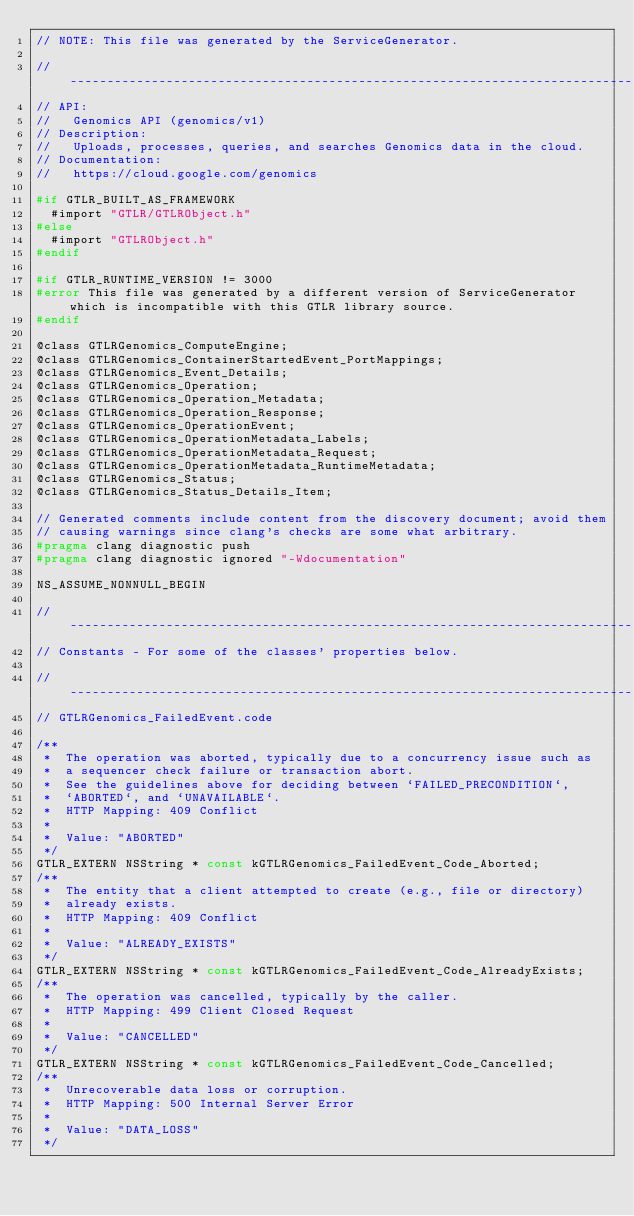Convert code to text. <code><loc_0><loc_0><loc_500><loc_500><_C_>// NOTE: This file was generated by the ServiceGenerator.

// ----------------------------------------------------------------------------
// API:
//   Genomics API (genomics/v1)
// Description:
//   Uploads, processes, queries, and searches Genomics data in the cloud.
// Documentation:
//   https://cloud.google.com/genomics

#if GTLR_BUILT_AS_FRAMEWORK
  #import "GTLR/GTLRObject.h"
#else
  #import "GTLRObject.h"
#endif

#if GTLR_RUNTIME_VERSION != 3000
#error This file was generated by a different version of ServiceGenerator which is incompatible with this GTLR library source.
#endif

@class GTLRGenomics_ComputeEngine;
@class GTLRGenomics_ContainerStartedEvent_PortMappings;
@class GTLRGenomics_Event_Details;
@class GTLRGenomics_Operation;
@class GTLRGenomics_Operation_Metadata;
@class GTLRGenomics_Operation_Response;
@class GTLRGenomics_OperationEvent;
@class GTLRGenomics_OperationMetadata_Labels;
@class GTLRGenomics_OperationMetadata_Request;
@class GTLRGenomics_OperationMetadata_RuntimeMetadata;
@class GTLRGenomics_Status;
@class GTLRGenomics_Status_Details_Item;

// Generated comments include content from the discovery document; avoid them
// causing warnings since clang's checks are some what arbitrary.
#pragma clang diagnostic push
#pragma clang diagnostic ignored "-Wdocumentation"

NS_ASSUME_NONNULL_BEGIN

// ----------------------------------------------------------------------------
// Constants - For some of the classes' properties below.

// ----------------------------------------------------------------------------
// GTLRGenomics_FailedEvent.code

/**
 *  The operation was aborted, typically due to a concurrency issue such as
 *  a sequencer check failure or transaction abort.
 *  See the guidelines above for deciding between `FAILED_PRECONDITION`,
 *  `ABORTED`, and `UNAVAILABLE`.
 *  HTTP Mapping: 409 Conflict
 *
 *  Value: "ABORTED"
 */
GTLR_EXTERN NSString * const kGTLRGenomics_FailedEvent_Code_Aborted;
/**
 *  The entity that a client attempted to create (e.g., file or directory)
 *  already exists.
 *  HTTP Mapping: 409 Conflict
 *
 *  Value: "ALREADY_EXISTS"
 */
GTLR_EXTERN NSString * const kGTLRGenomics_FailedEvent_Code_AlreadyExists;
/**
 *  The operation was cancelled, typically by the caller.
 *  HTTP Mapping: 499 Client Closed Request
 *
 *  Value: "CANCELLED"
 */
GTLR_EXTERN NSString * const kGTLRGenomics_FailedEvent_Code_Cancelled;
/**
 *  Unrecoverable data loss or corruption.
 *  HTTP Mapping: 500 Internal Server Error
 *
 *  Value: "DATA_LOSS"
 */</code> 